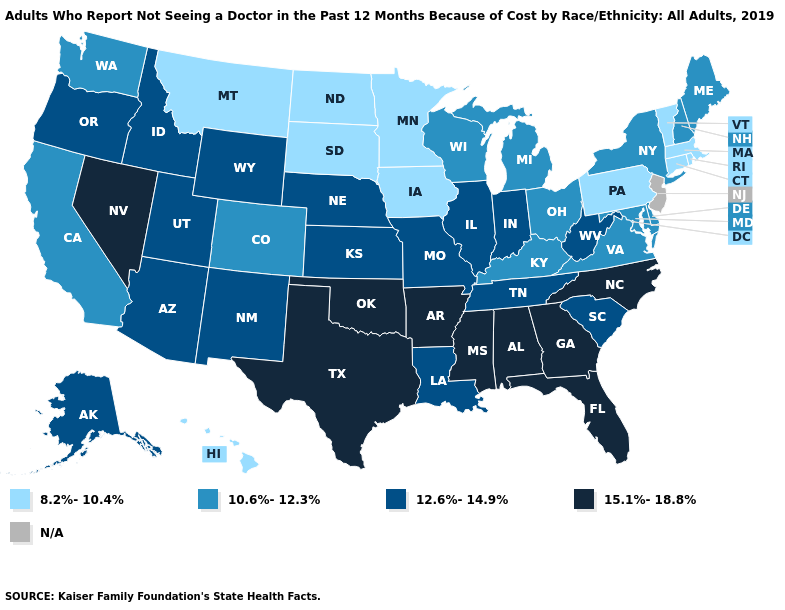What is the lowest value in the Northeast?
Write a very short answer. 8.2%-10.4%. What is the value of Georgia?
Answer briefly. 15.1%-18.8%. What is the lowest value in the Northeast?
Quick response, please. 8.2%-10.4%. What is the highest value in the USA?
Keep it brief. 15.1%-18.8%. What is the value of Georgia?
Keep it brief. 15.1%-18.8%. Name the states that have a value in the range 10.6%-12.3%?
Quick response, please. California, Colorado, Delaware, Kentucky, Maine, Maryland, Michigan, New Hampshire, New York, Ohio, Virginia, Washington, Wisconsin. Name the states that have a value in the range 15.1%-18.8%?
Short answer required. Alabama, Arkansas, Florida, Georgia, Mississippi, Nevada, North Carolina, Oklahoma, Texas. Which states hav the highest value in the Northeast?
Quick response, please. Maine, New Hampshire, New York. Among the states that border West Virginia , does Pennsylvania have the lowest value?
Answer briefly. Yes. Among the states that border Minnesota , does Wisconsin have the lowest value?
Write a very short answer. No. What is the highest value in the USA?
Be succinct. 15.1%-18.8%. Which states hav the highest value in the West?
Give a very brief answer. Nevada. Name the states that have a value in the range 8.2%-10.4%?
Concise answer only. Connecticut, Hawaii, Iowa, Massachusetts, Minnesota, Montana, North Dakota, Pennsylvania, Rhode Island, South Dakota, Vermont. Among the states that border Nevada , does California have the highest value?
Be succinct. No. What is the value of Oklahoma?
Keep it brief. 15.1%-18.8%. 